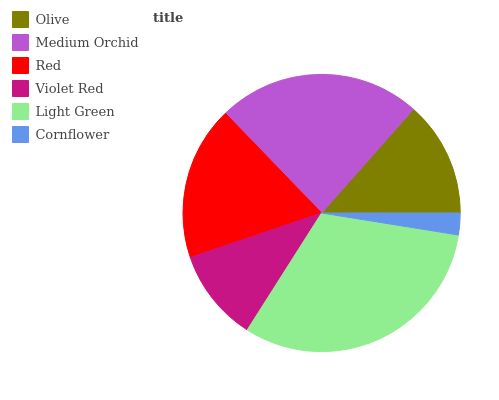Is Cornflower the minimum?
Answer yes or no. Yes. Is Light Green the maximum?
Answer yes or no. Yes. Is Medium Orchid the minimum?
Answer yes or no. No. Is Medium Orchid the maximum?
Answer yes or no. No. Is Medium Orchid greater than Olive?
Answer yes or no. Yes. Is Olive less than Medium Orchid?
Answer yes or no. Yes. Is Olive greater than Medium Orchid?
Answer yes or no. No. Is Medium Orchid less than Olive?
Answer yes or no. No. Is Red the high median?
Answer yes or no. Yes. Is Olive the low median?
Answer yes or no. Yes. Is Light Green the high median?
Answer yes or no. No. Is Violet Red the low median?
Answer yes or no. No. 